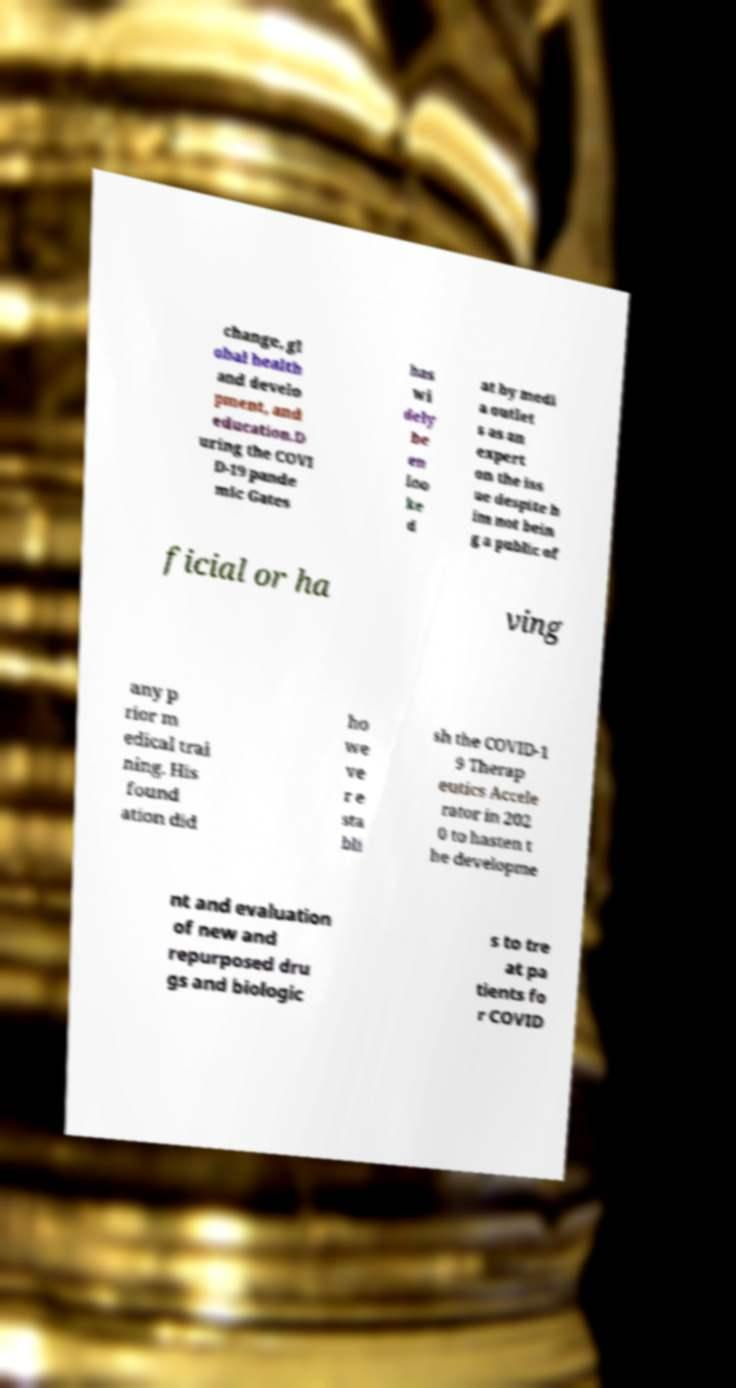Can you read and provide the text displayed in the image?This photo seems to have some interesting text. Can you extract and type it out for me? change, gl obal health and develo pment, and education.D uring the COVI D-19 pande mic Gates has wi dely be en loo ke d at by medi a outlet s as an expert on the iss ue despite h im not bein g a public of ficial or ha ving any p rior m edical trai ning. His found ation did ho we ve r e sta bli sh the COVID-1 9 Therap eutics Accele rator in 202 0 to hasten t he developme nt and evaluation of new and repurposed dru gs and biologic s to tre at pa tients fo r COVID 